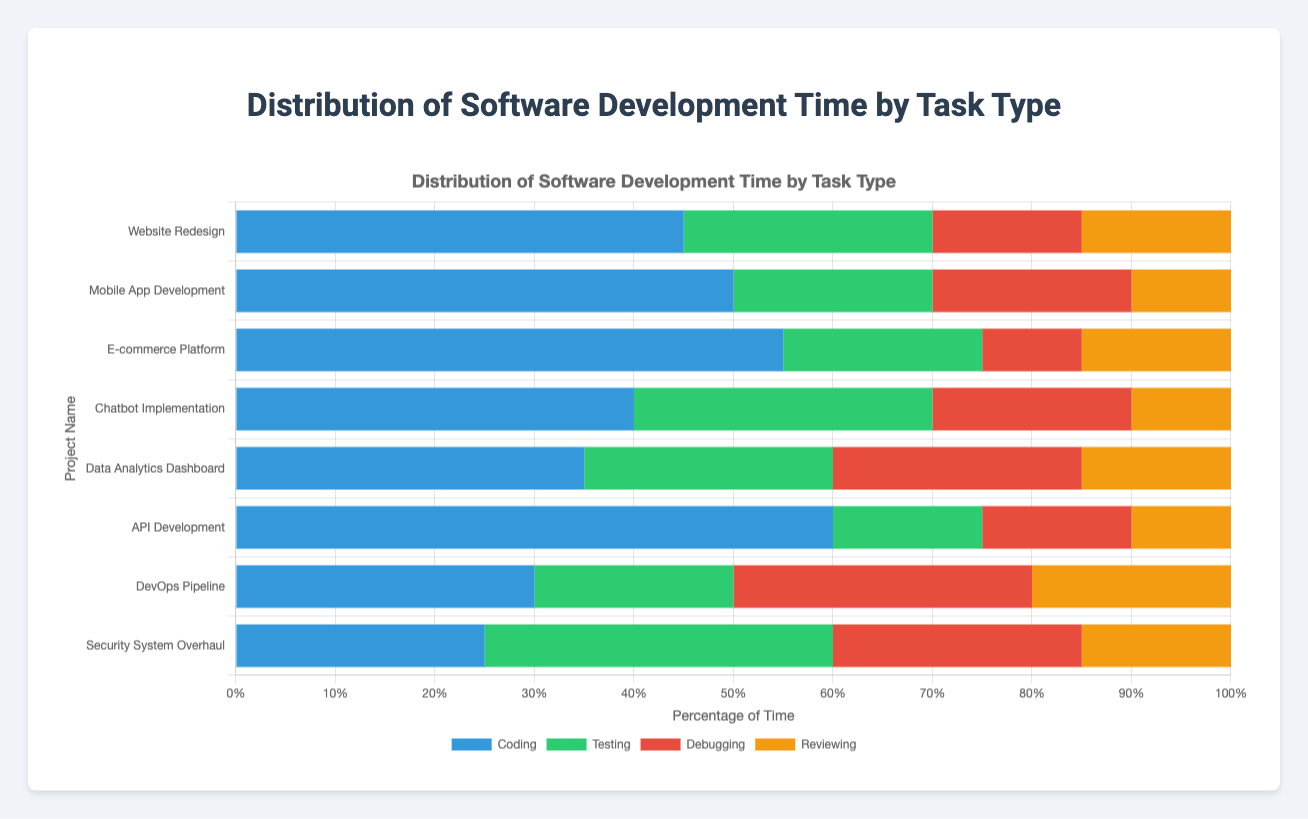Which project has the highest percentage of coding time? By looking at the blue segments in each bar (which represents coding time), the longest one belongs to "API Development" with 60%.
Answer: API Development Which project has the smallest proportion of testing time? The green segments (representing testing time) are smallest in "API Development" and "Mobile App Development", both at 15%.
Answer: API Development, Mobile App Development What's the total percentage of debugging time for "Security System Overhaul" and "DevOps Pipeline"? "Security System Overhaul" has 25% and "DevOps Pipeline" has 30% for debugging. Adding these together gives 25% + 30% = 55%.
Answer: 55% Which project has the highest proportion of reviewing time? The yellow segments (representing reviewing time) are somewhat equal across several projects, but the largest yellow segment seems to be 20% for "DevOps Pipeline".
Answer: DevOps Pipeline Compare the testing times of "Chatbot Implementation" and "DevOps Pipeline". Which project spent more time on testing? "Chatbot Implementation" has a green segment of 30% while "DevOps Pipeline" has 20% for testing. Therefore, "Chatbot Implementation" spent more time on testing.
Answer: Chatbot Implementation What's the average coding time across all projects? Sum of coding times: 45 + 50 + 55 + 40 + 35 + 60 + 30 + 25 = 340. Number of projects = 8. Average coding time = 340 / 8 = 42.5%.
Answer: 42.5% Which task type has the smallest percentage in "Mobile App Development"? For "Mobile App Development", the percentages are 50% (coding), 20% (testing), 20% (debugging), and 10% (reviewing). Reviewing is the smallest with 10%.
Answer: Reviewing By how much does the percentage of debugging time in "Website Redesign" exceed that in "E-commerce Platform"? Debugging time is 15% in "Website Redesign" and 10% in "E-commerce Platform". The difference is 15% - 10% = 5%.
Answer: 5% What is the cumulative percentage of time spent on non-coding tasks for "API Development"? For "API Development", testing (15%) + debugging (15%) + reviewing (10%) = 40%.
Answer: 40% Which project has the largest proportion of non-coding tasks in total? By comparing the sum of green, red, and yellow segments (representing non-coding tasks), "Security System Overhaul" has the most with testing (35%) + debugging (25%) + reviewing (15%) = 75%.
Answer: Security System Overhaul 